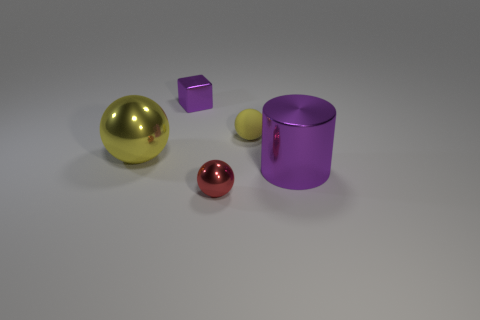What shape is the metal thing that is both right of the small shiny block and on the left side of the big purple object?
Offer a terse response. Sphere. How many objects are either metal things in front of the tiny purple shiny thing or yellow spheres that are on the left side of the tiny purple shiny cube?
Your answer should be very brief. 3. Are there the same number of red objects that are to the left of the big yellow metal ball and big yellow objects right of the big purple cylinder?
Your response must be concise. Yes. The purple shiny thing behind the yellow sphere left of the tiny purple thing is what shape?
Your response must be concise. Cube. Are there any tiny yellow rubber objects that have the same shape as the small red thing?
Give a very brief answer. Yes. What number of yellow matte objects are there?
Your answer should be compact. 1. Is the material of the yellow object on the right side of the tiny block the same as the tiny red thing?
Keep it short and to the point. No. Are there any yellow matte balls that have the same size as the red thing?
Make the answer very short. Yes. There is a big purple metal thing; is it the same shape as the small metal object that is behind the red sphere?
Your response must be concise. No. Are there any large metallic objects that are on the right side of the small shiny object in front of the large thing on the right side of the large yellow shiny sphere?
Give a very brief answer. Yes. 